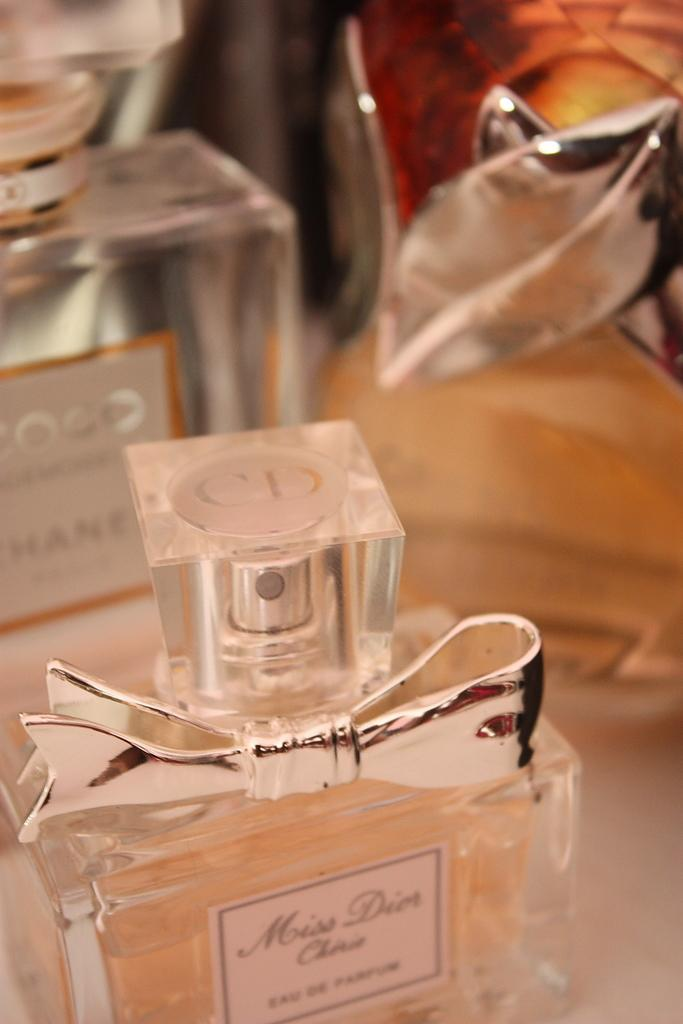<image>
Relay a brief, clear account of the picture shown. several perfume bottles, one is coco chanel and front one is miss dior 